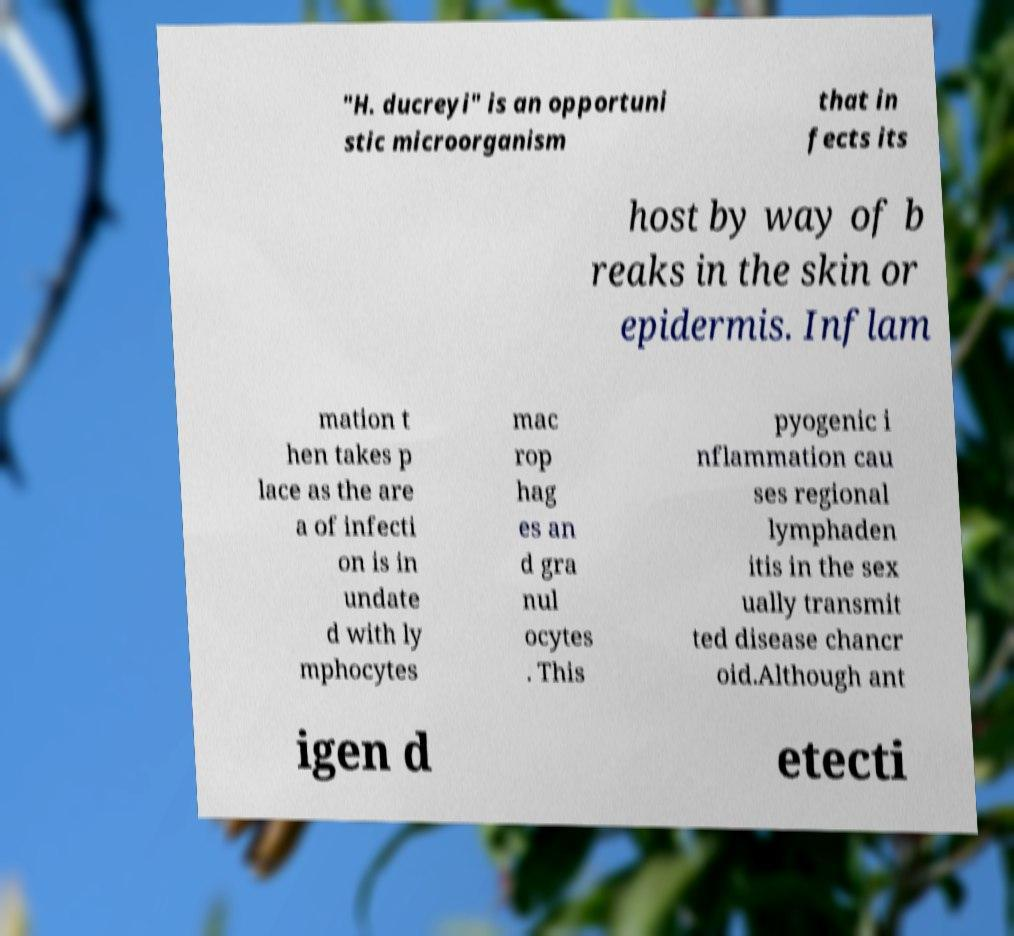What messages or text are displayed in this image? I need them in a readable, typed format. "H. ducreyi" is an opportuni stic microorganism that in fects its host by way of b reaks in the skin or epidermis. Inflam mation t hen takes p lace as the are a of infecti on is in undate d with ly mphocytes mac rop hag es an d gra nul ocytes . This pyogenic i nflammation cau ses regional lymphaden itis in the sex ually transmit ted disease chancr oid.Although ant igen d etecti 